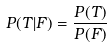Convert formula to latex. <formula><loc_0><loc_0><loc_500><loc_500>P ( T | F ) = \frac { P ( T ) } { P ( F ) }</formula> 